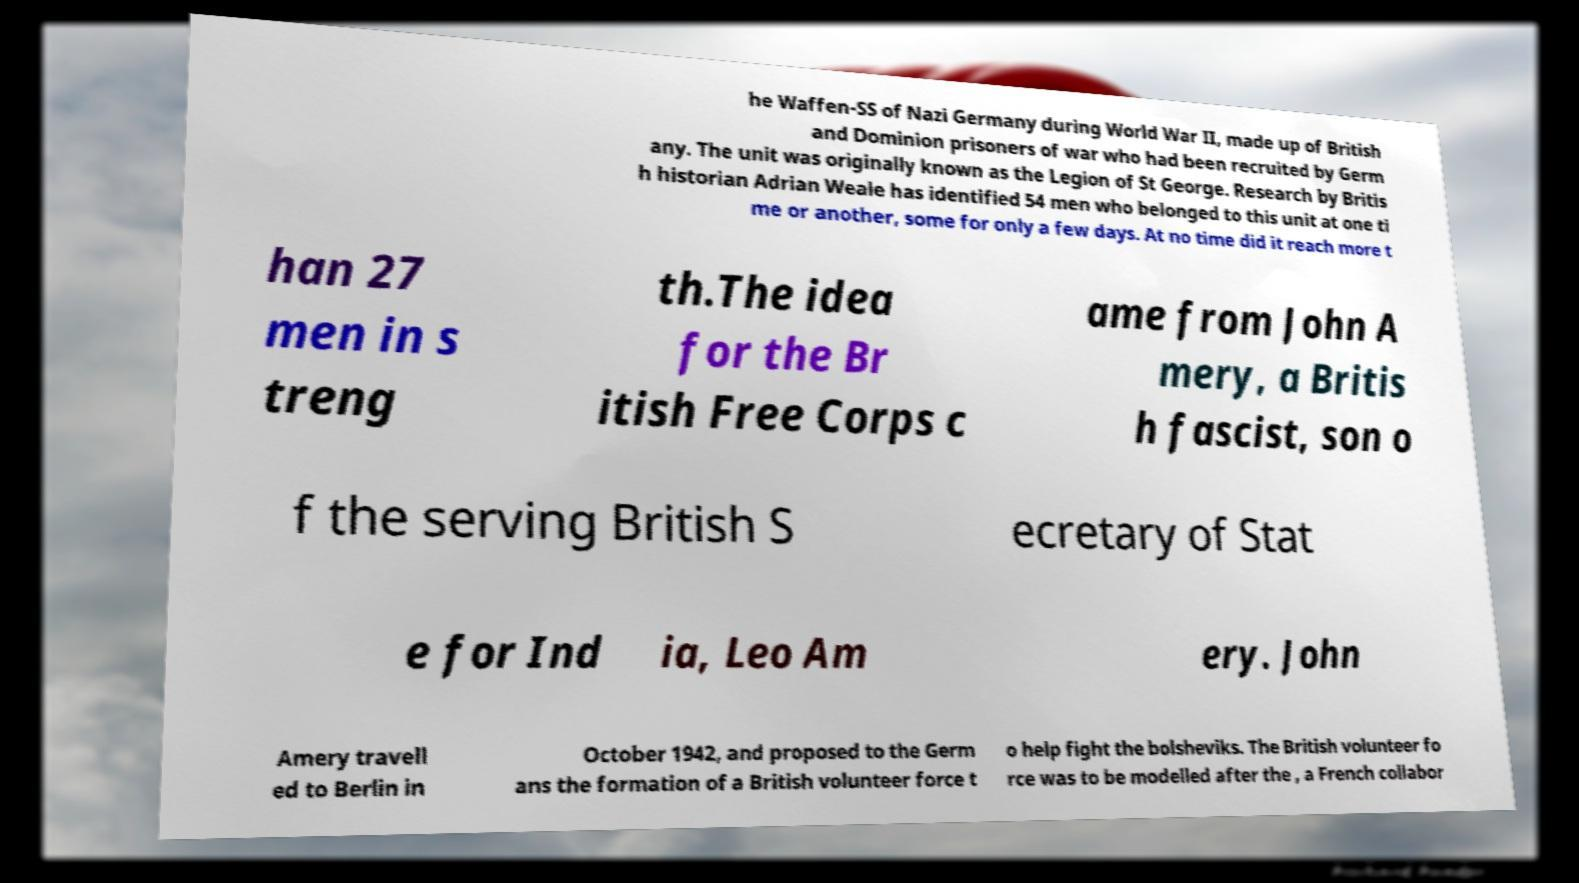Please read and relay the text visible in this image. What does it say? he Waffen-SS of Nazi Germany during World War II, made up of British and Dominion prisoners of war who had been recruited by Germ any. The unit was originally known as the Legion of St George. Research by Britis h historian Adrian Weale has identified 54 men who belonged to this unit at one ti me or another, some for only a few days. At no time did it reach more t han 27 men in s treng th.The idea for the Br itish Free Corps c ame from John A mery, a Britis h fascist, son o f the serving British S ecretary of Stat e for Ind ia, Leo Am ery. John Amery travell ed to Berlin in October 1942, and proposed to the Germ ans the formation of a British volunteer force t o help fight the bolsheviks. The British volunteer fo rce was to be modelled after the , a French collabor 